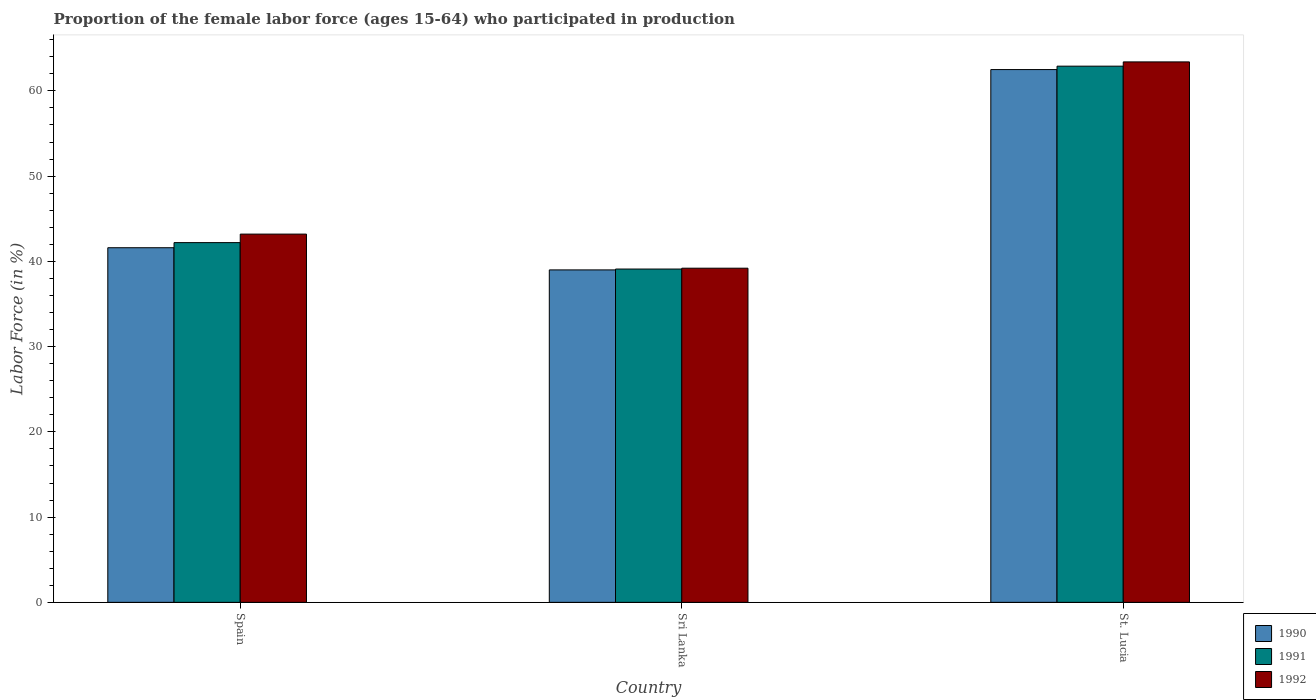How many different coloured bars are there?
Keep it short and to the point. 3. How many groups of bars are there?
Ensure brevity in your answer.  3. Are the number of bars per tick equal to the number of legend labels?
Your answer should be very brief. Yes. Are the number of bars on each tick of the X-axis equal?
Give a very brief answer. Yes. How many bars are there on the 3rd tick from the left?
Offer a terse response. 3. What is the label of the 2nd group of bars from the left?
Keep it short and to the point. Sri Lanka. In how many cases, is the number of bars for a given country not equal to the number of legend labels?
Give a very brief answer. 0. What is the proportion of the female labor force who participated in production in 1992 in St. Lucia?
Keep it short and to the point. 63.4. Across all countries, what is the maximum proportion of the female labor force who participated in production in 1991?
Your answer should be very brief. 62.9. Across all countries, what is the minimum proportion of the female labor force who participated in production in 1992?
Your answer should be compact. 39.2. In which country was the proportion of the female labor force who participated in production in 1991 maximum?
Your answer should be very brief. St. Lucia. In which country was the proportion of the female labor force who participated in production in 1991 minimum?
Keep it short and to the point. Sri Lanka. What is the total proportion of the female labor force who participated in production in 1990 in the graph?
Make the answer very short. 143.1. What is the difference between the proportion of the female labor force who participated in production in 1990 in Spain and that in Sri Lanka?
Your answer should be very brief. 2.6. What is the difference between the proportion of the female labor force who participated in production in 1990 in St. Lucia and the proportion of the female labor force who participated in production in 1991 in Sri Lanka?
Your response must be concise. 23.4. What is the average proportion of the female labor force who participated in production in 1990 per country?
Provide a succinct answer. 47.7. What is the difference between the proportion of the female labor force who participated in production of/in 1990 and proportion of the female labor force who participated in production of/in 1991 in Sri Lanka?
Make the answer very short. -0.1. What is the ratio of the proportion of the female labor force who participated in production in 1992 in Spain to that in St. Lucia?
Your answer should be very brief. 0.68. Is the proportion of the female labor force who participated in production in 1991 in Sri Lanka less than that in St. Lucia?
Provide a short and direct response. Yes. Is the difference between the proportion of the female labor force who participated in production in 1990 in Spain and St. Lucia greater than the difference between the proportion of the female labor force who participated in production in 1991 in Spain and St. Lucia?
Make the answer very short. No. What is the difference between the highest and the second highest proportion of the female labor force who participated in production in 1990?
Your answer should be very brief. -20.9. In how many countries, is the proportion of the female labor force who participated in production in 1990 greater than the average proportion of the female labor force who participated in production in 1990 taken over all countries?
Provide a short and direct response. 1. Is the sum of the proportion of the female labor force who participated in production in 1990 in Spain and St. Lucia greater than the maximum proportion of the female labor force who participated in production in 1991 across all countries?
Ensure brevity in your answer.  Yes. What does the 2nd bar from the right in Spain represents?
Give a very brief answer. 1991. Is it the case that in every country, the sum of the proportion of the female labor force who participated in production in 1990 and proportion of the female labor force who participated in production in 1992 is greater than the proportion of the female labor force who participated in production in 1991?
Make the answer very short. Yes. How many bars are there?
Your answer should be compact. 9. What is the difference between two consecutive major ticks on the Y-axis?
Offer a very short reply. 10. Does the graph contain grids?
Your answer should be very brief. No. How many legend labels are there?
Offer a very short reply. 3. How are the legend labels stacked?
Make the answer very short. Vertical. What is the title of the graph?
Provide a short and direct response. Proportion of the female labor force (ages 15-64) who participated in production. What is the label or title of the X-axis?
Provide a short and direct response. Country. What is the label or title of the Y-axis?
Offer a terse response. Labor Force (in %). What is the Labor Force (in %) of 1990 in Spain?
Offer a terse response. 41.6. What is the Labor Force (in %) in 1991 in Spain?
Your answer should be very brief. 42.2. What is the Labor Force (in %) in 1992 in Spain?
Provide a short and direct response. 43.2. What is the Labor Force (in %) of 1991 in Sri Lanka?
Offer a very short reply. 39.1. What is the Labor Force (in %) of 1992 in Sri Lanka?
Keep it short and to the point. 39.2. What is the Labor Force (in %) in 1990 in St. Lucia?
Offer a very short reply. 62.5. What is the Labor Force (in %) in 1991 in St. Lucia?
Give a very brief answer. 62.9. What is the Labor Force (in %) of 1992 in St. Lucia?
Ensure brevity in your answer.  63.4. Across all countries, what is the maximum Labor Force (in %) of 1990?
Provide a succinct answer. 62.5. Across all countries, what is the maximum Labor Force (in %) in 1991?
Offer a very short reply. 62.9. Across all countries, what is the maximum Labor Force (in %) of 1992?
Keep it short and to the point. 63.4. Across all countries, what is the minimum Labor Force (in %) of 1991?
Offer a terse response. 39.1. Across all countries, what is the minimum Labor Force (in %) of 1992?
Ensure brevity in your answer.  39.2. What is the total Labor Force (in %) in 1990 in the graph?
Your answer should be compact. 143.1. What is the total Labor Force (in %) in 1991 in the graph?
Offer a terse response. 144.2. What is the total Labor Force (in %) of 1992 in the graph?
Your answer should be very brief. 145.8. What is the difference between the Labor Force (in %) of 1990 in Spain and that in Sri Lanka?
Make the answer very short. 2.6. What is the difference between the Labor Force (in %) of 1990 in Spain and that in St. Lucia?
Provide a succinct answer. -20.9. What is the difference between the Labor Force (in %) in 1991 in Spain and that in St. Lucia?
Your response must be concise. -20.7. What is the difference between the Labor Force (in %) in 1992 in Spain and that in St. Lucia?
Offer a very short reply. -20.2. What is the difference between the Labor Force (in %) of 1990 in Sri Lanka and that in St. Lucia?
Give a very brief answer. -23.5. What is the difference between the Labor Force (in %) in 1991 in Sri Lanka and that in St. Lucia?
Your answer should be very brief. -23.8. What is the difference between the Labor Force (in %) of 1992 in Sri Lanka and that in St. Lucia?
Provide a short and direct response. -24.2. What is the difference between the Labor Force (in %) of 1990 in Spain and the Labor Force (in %) of 1991 in Sri Lanka?
Keep it short and to the point. 2.5. What is the difference between the Labor Force (in %) of 1990 in Spain and the Labor Force (in %) of 1992 in Sri Lanka?
Your answer should be very brief. 2.4. What is the difference between the Labor Force (in %) in 1991 in Spain and the Labor Force (in %) in 1992 in Sri Lanka?
Your response must be concise. 3. What is the difference between the Labor Force (in %) in 1990 in Spain and the Labor Force (in %) in 1991 in St. Lucia?
Your answer should be compact. -21.3. What is the difference between the Labor Force (in %) of 1990 in Spain and the Labor Force (in %) of 1992 in St. Lucia?
Offer a very short reply. -21.8. What is the difference between the Labor Force (in %) in 1991 in Spain and the Labor Force (in %) in 1992 in St. Lucia?
Your response must be concise. -21.2. What is the difference between the Labor Force (in %) of 1990 in Sri Lanka and the Labor Force (in %) of 1991 in St. Lucia?
Your answer should be compact. -23.9. What is the difference between the Labor Force (in %) in 1990 in Sri Lanka and the Labor Force (in %) in 1992 in St. Lucia?
Provide a succinct answer. -24.4. What is the difference between the Labor Force (in %) in 1991 in Sri Lanka and the Labor Force (in %) in 1992 in St. Lucia?
Your response must be concise. -24.3. What is the average Labor Force (in %) of 1990 per country?
Ensure brevity in your answer.  47.7. What is the average Labor Force (in %) of 1991 per country?
Offer a terse response. 48.07. What is the average Labor Force (in %) of 1992 per country?
Provide a short and direct response. 48.6. What is the difference between the Labor Force (in %) in 1990 and Labor Force (in %) in 1991 in Spain?
Provide a short and direct response. -0.6. What is the difference between the Labor Force (in %) in 1990 and Labor Force (in %) in 1991 in Sri Lanka?
Keep it short and to the point. -0.1. What is the difference between the Labor Force (in %) in 1990 and Labor Force (in %) in 1992 in Sri Lanka?
Keep it short and to the point. -0.2. What is the difference between the Labor Force (in %) in 1990 and Labor Force (in %) in 1991 in St. Lucia?
Your answer should be compact. -0.4. What is the difference between the Labor Force (in %) in 1990 and Labor Force (in %) in 1992 in St. Lucia?
Ensure brevity in your answer.  -0.9. What is the difference between the Labor Force (in %) in 1991 and Labor Force (in %) in 1992 in St. Lucia?
Offer a very short reply. -0.5. What is the ratio of the Labor Force (in %) of 1990 in Spain to that in Sri Lanka?
Give a very brief answer. 1.07. What is the ratio of the Labor Force (in %) in 1991 in Spain to that in Sri Lanka?
Your answer should be compact. 1.08. What is the ratio of the Labor Force (in %) in 1992 in Spain to that in Sri Lanka?
Your answer should be very brief. 1.1. What is the ratio of the Labor Force (in %) in 1990 in Spain to that in St. Lucia?
Your answer should be compact. 0.67. What is the ratio of the Labor Force (in %) of 1991 in Spain to that in St. Lucia?
Keep it short and to the point. 0.67. What is the ratio of the Labor Force (in %) of 1992 in Spain to that in St. Lucia?
Ensure brevity in your answer.  0.68. What is the ratio of the Labor Force (in %) of 1990 in Sri Lanka to that in St. Lucia?
Ensure brevity in your answer.  0.62. What is the ratio of the Labor Force (in %) in 1991 in Sri Lanka to that in St. Lucia?
Offer a very short reply. 0.62. What is the ratio of the Labor Force (in %) of 1992 in Sri Lanka to that in St. Lucia?
Your answer should be compact. 0.62. What is the difference between the highest and the second highest Labor Force (in %) in 1990?
Your answer should be compact. 20.9. What is the difference between the highest and the second highest Labor Force (in %) in 1991?
Offer a very short reply. 20.7. What is the difference between the highest and the second highest Labor Force (in %) of 1992?
Your answer should be very brief. 20.2. What is the difference between the highest and the lowest Labor Force (in %) of 1991?
Make the answer very short. 23.8. What is the difference between the highest and the lowest Labor Force (in %) in 1992?
Give a very brief answer. 24.2. 